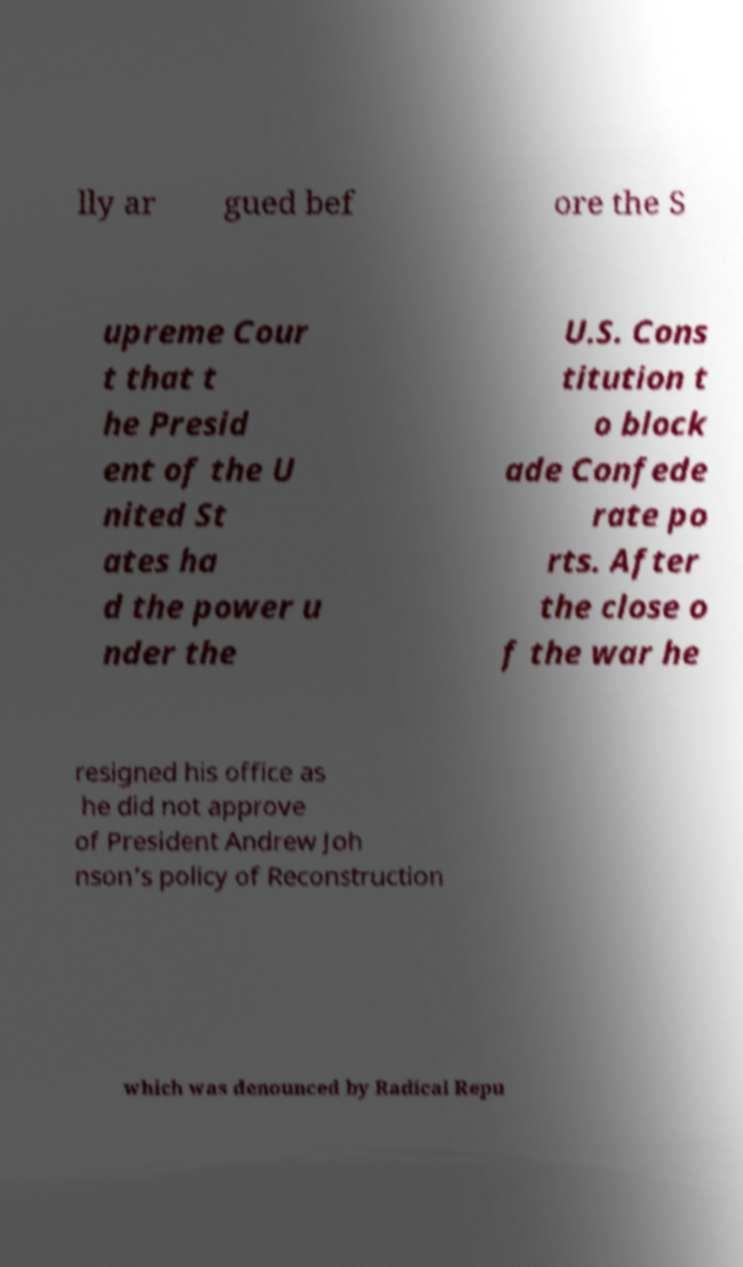There's text embedded in this image that I need extracted. Can you transcribe it verbatim? lly ar gued bef ore the S upreme Cour t that t he Presid ent of the U nited St ates ha d the power u nder the U.S. Cons titution t o block ade Confede rate po rts. After the close o f the war he resigned his office as he did not approve of President Andrew Joh nson's policy of Reconstruction which was denounced by Radical Repu 